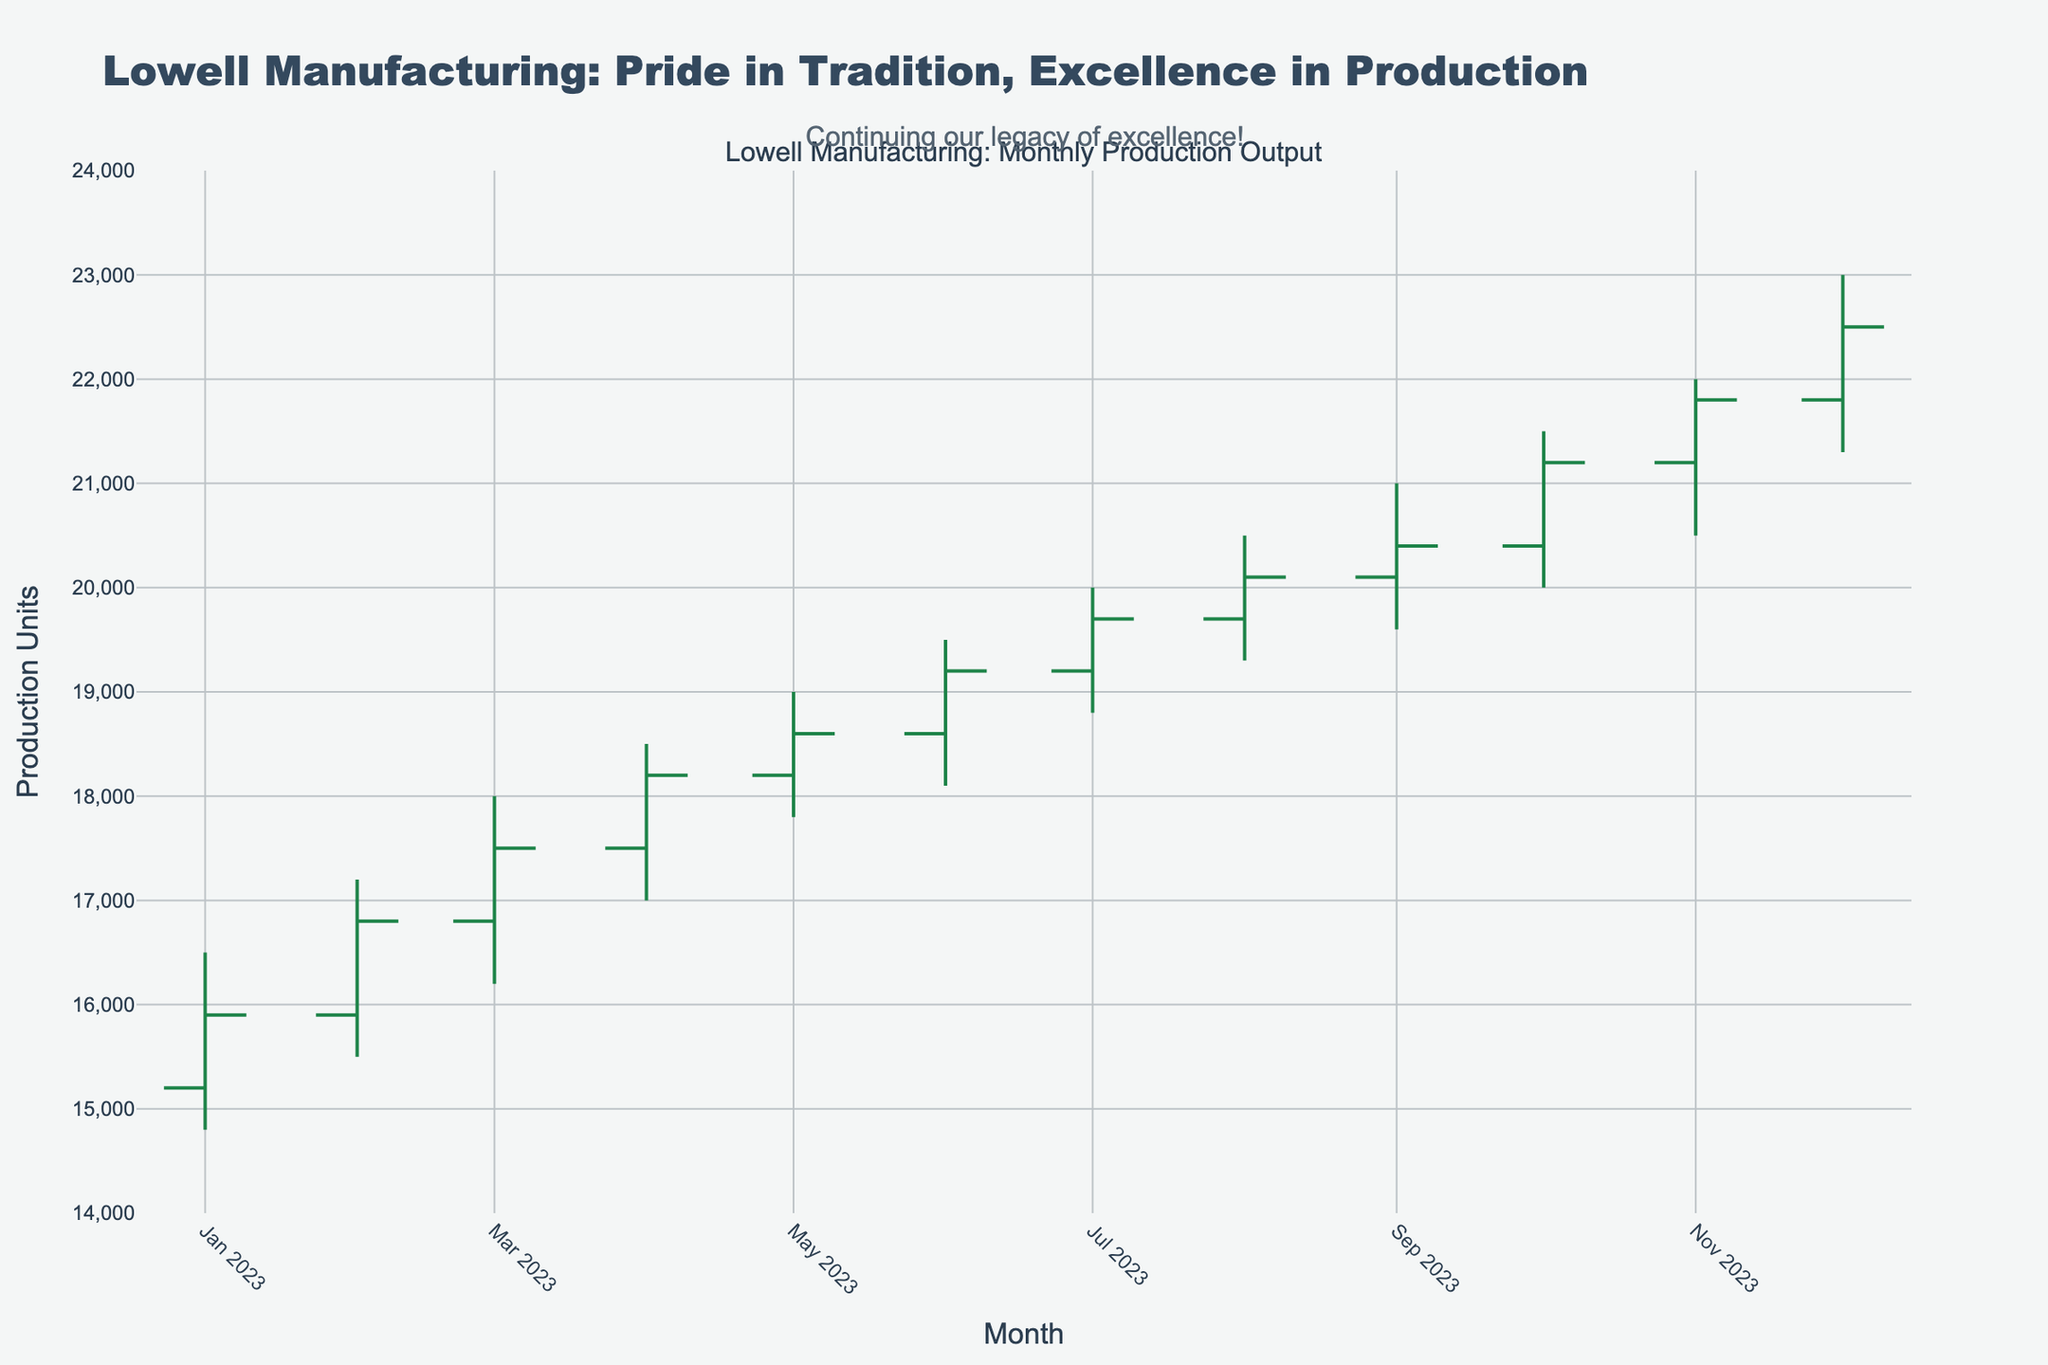What's the highest production output recorded in 2023? The highest production output can be determined by looking for the maximum value in the 'High' column of the OHLC chart. The highest value is 23000 units in December 2023.
Answer: 23000 What's the lowest production output recorded in 2023? The lowest production output is found by locating the minimum value in the 'Low' column of the OHLC chart. The lowest value is 14800 units in January 2023.
Answer: 14800 What month had the highest opening production output? To find the month with the highest opening production output, look for the maximum value in the 'Open' column. The highest opening value is 21800 units in December 2023.
Answer: December 2023 How much did the production output increase from January to December? The increase in production output can be calculated by subtracting the 'Close' value of January from the 'Close' value of December. The values are 22500 (December) - 15900 (January) = 6600 units.
Answer: 6600 What was the trend in the production output from May to August? To determine the trend, observe the 'Close' values from May to August. The values increase consecutively from 18600, 19200, 19700, to 20100, indicating an upward trend.
Answer: Upward Did any month have a production output that decreased from the opening to the closing value? Compare 'Open' and 'Close' values for each month. February is an example where the 'Open' (16800) is greater than the 'Close' (16800), but as they are equal, consider no noticeable decrease.
Answer: No significant decrease 